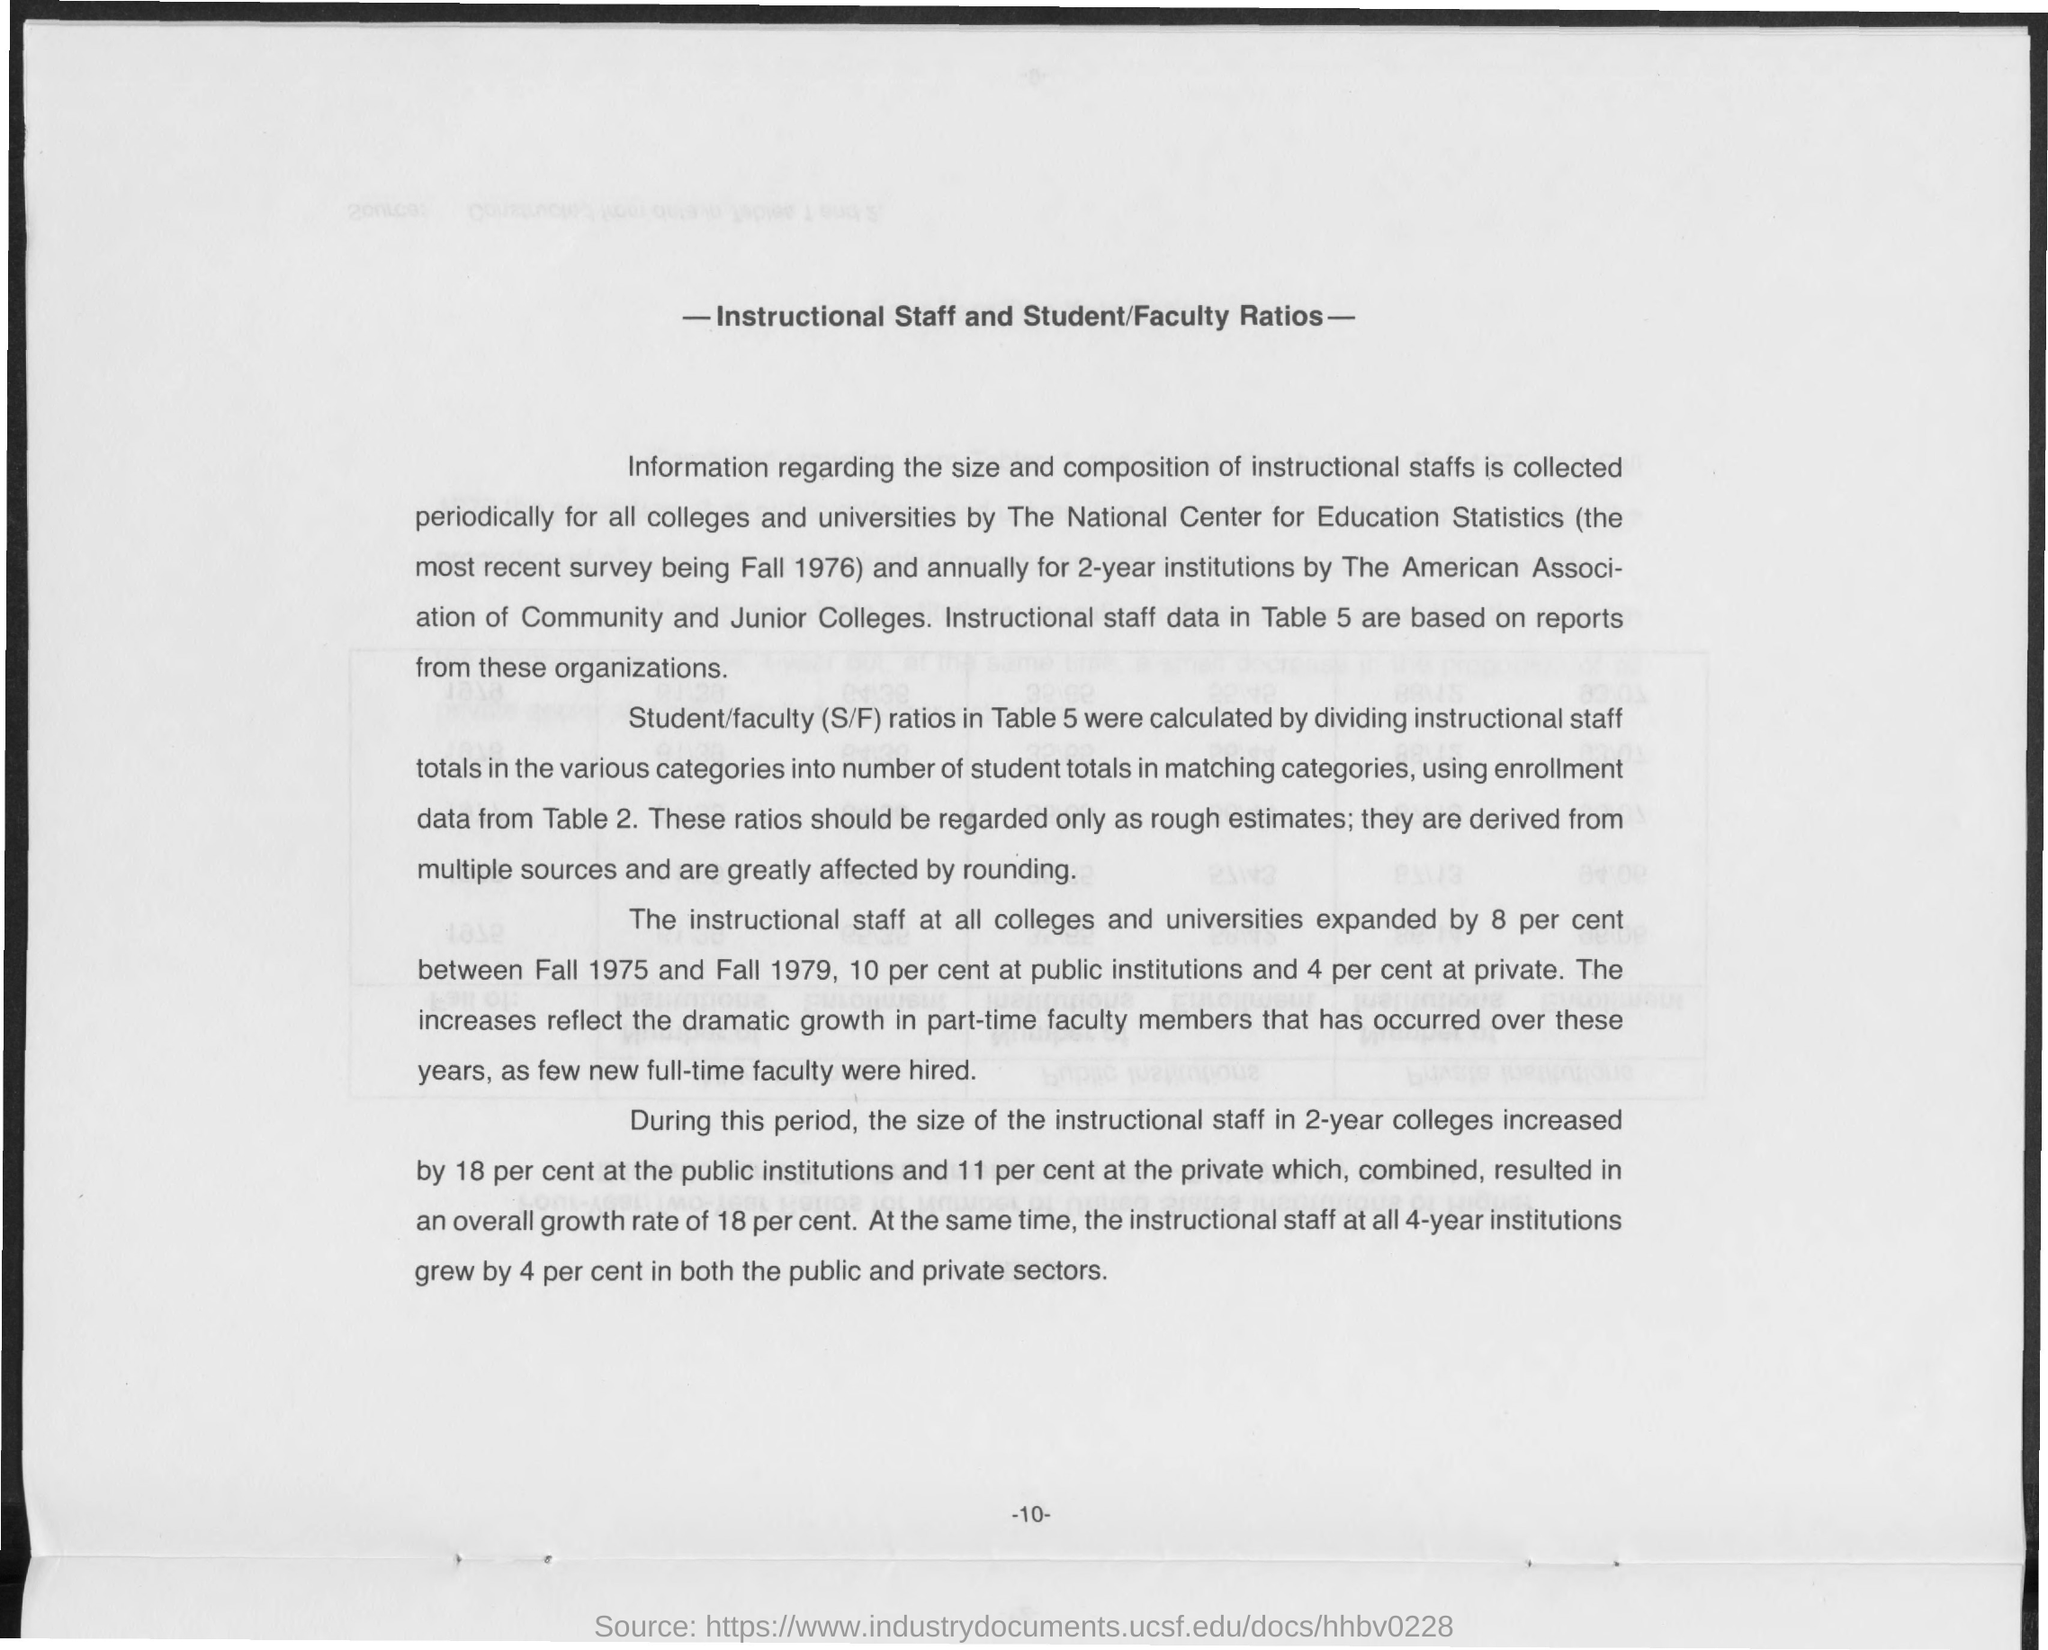Indicate a few pertinent items in this graphic. The document titled 'INSTRUCTIONAL STAFF AND STUDENT/FACULTY RATIOS' provides information on staffing ratios for instructional staff and the student-to-faculty ratio at the institution. 